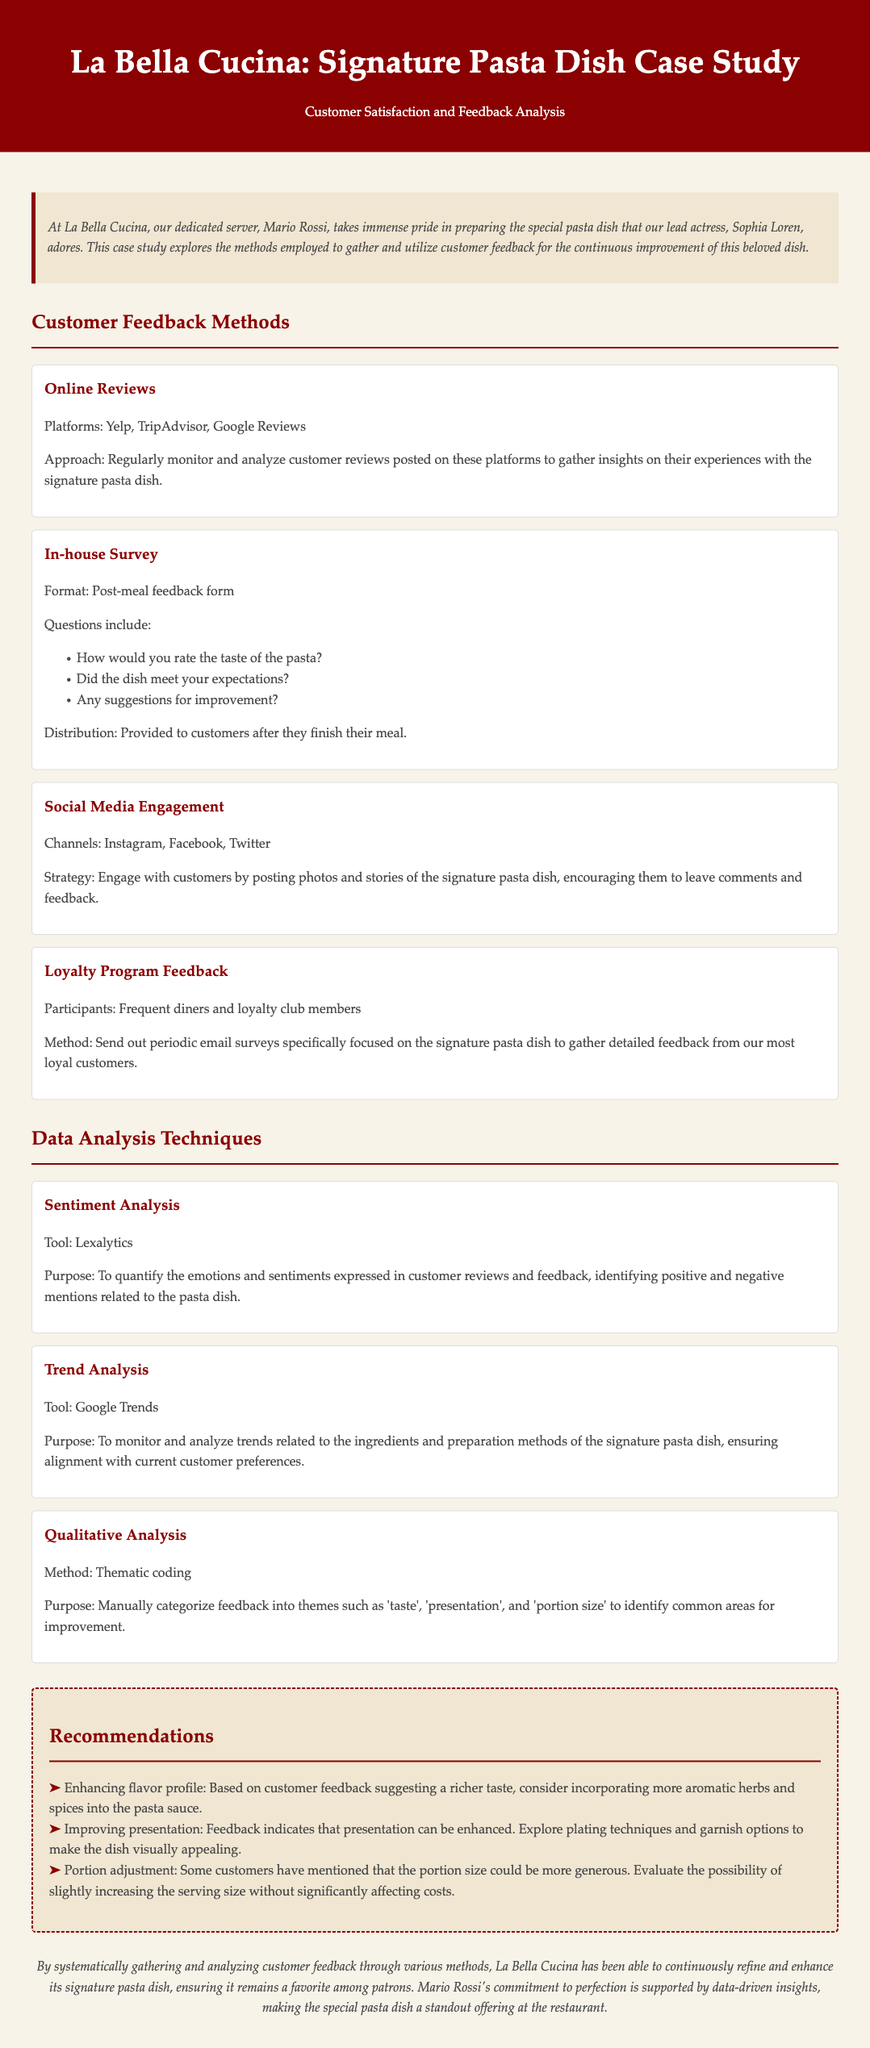What are the platforms used for online reviews? The document lists Yelp, TripAdvisor, and Google Reviews as platforms for online reviews.
Answer: Yelp, TripAdvisor, Google Reviews What method is used to analyze customer sentiments? The document states that Lexalytics is the tool used for sentiment analysis.
Answer: Lexalytics What type of analysis is performed to identify common areas for improvement? The document mentions thematic coding as the method for qualitative analysis.
Answer: Thematic coding How many questions are included in the in-house survey? The document shows three key questions are included in the in-house survey.
Answer: Three What recommendation is made regarding the flavor profile? The document states that enhancing the flavor profile by incorporating more aromatic herbs and spices is recommended.
Answer: Enhancing flavor profile Which social media channels are used for customer engagement? The document indicates Instagram, Facebook, and Twitter as the channels used for social media engagement.
Answer: Instagram, Facebook, Twitter What problem related to portion size is mentioned in customer feedback? The document reveals that some customers have mentioned that the portion size could be more generous.
Answer: More generous Who is the dedicated server preparing the special pasta dish? The document names Mario Rossi as the dedicated server responsible for preparing the dish.
Answer: Mario Rossi 